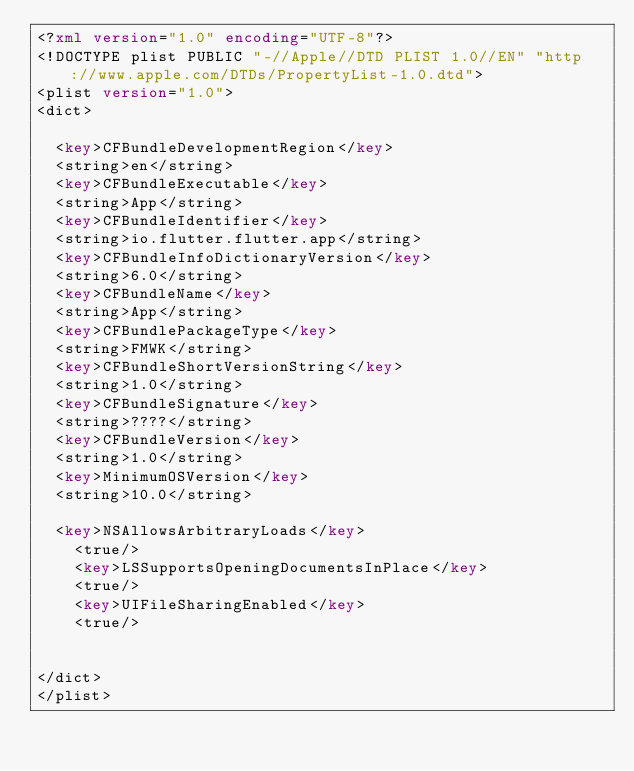<code> <loc_0><loc_0><loc_500><loc_500><_XML_><?xml version="1.0" encoding="UTF-8"?>
<!DOCTYPE plist PUBLIC "-//Apple//DTD PLIST 1.0//EN" "http://www.apple.com/DTDs/PropertyList-1.0.dtd">
<plist version="1.0">
<dict>

	<key>CFBundleDevelopmentRegion</key>
	<string>en</string>
	<key>CFBundleExecutable</key>
	<string>App</string>
	<key>CFBundleIdentifier</key>
	<string>io.flutter.flutter.app</string>
	<key>CFBundleInfoDictionaryVersion</key>
	<string>6.0</string>
	<key>CFBundleName</key>
	<string>App</string>
	<key>CFBundlePackageType</key>
	<string>FMWK</string>
	<key>CFBundleShortVersionString</key>
	<string>1.0</string>
	<key>CFBundleSignature</key>
	<string>????</string>
	<key>CFBundleVersion</key>
	<string>1.0</string>
	<key>MinimumOSVersion</key>
	<string>10.0</string>

	<key>NSAllowsArbitraryLoads</key>
    <true/>
    <key>LSSupportsOpeningDocumentsInPlace</key>
    <true/>
    <key>UIFileSharingEnabled</key>
    <true/>


</dict>
</plist>
</code> 